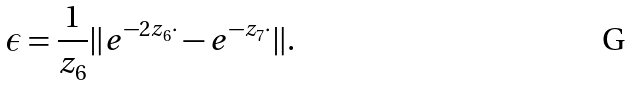Convert formula to latex. <formula><loc_0><loc_0><loc_500><loc_500>\epsilon = \frac { 1 } { z _ { 6 } } \| e ^ { - 2 z _ { 6 } \cdot } - e ^ { - z _ { 7 } \cdot } \| .</formula> 